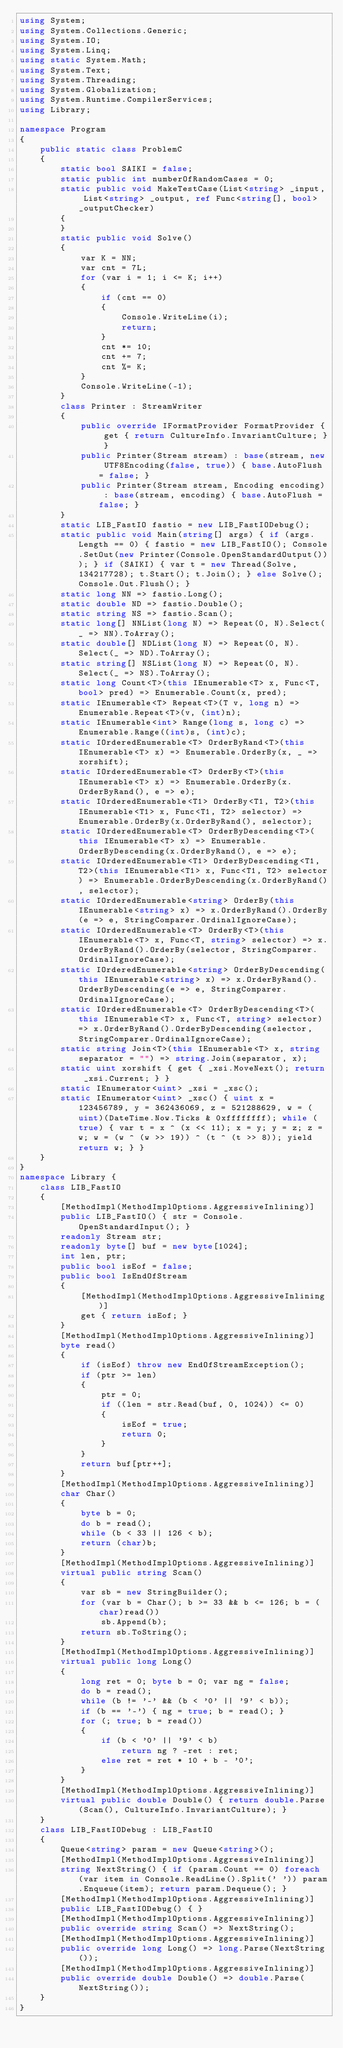Convert code to text. <code><loc_0><loc_0><loc_500><loc_500><_C#_>using System;
using System.Collections.Generic;
using System.IO;
using System.Linq;
using static System.Math;
using System.Text;
using System.Threading;
using System.Globalization;
using System.Runtime.CompilerServices;
using Library;

namespace Program
{
    public static class ProblemC
    {
        static bool SAIKI = false;
        static public int numberOfRandomCases = 0;
        static public void MakeTestCase(List<string> _input, List<string> _output, ref Func<string[], bool> _outputChecker)
        {
        }
        static public void Solve()
        {
            var K = NN;
            var cnt = 7L;
            for (var i = 1; i <= K; i++)
            {
                if (cnt == 0)
                {
                    Console.WriteLine(i);
                    return;
                }
                cnt *= 10;
                cnt += 7;
                cnt %= K;
            }
            Console.WriteLine(-1);
        }
        class Printer : StreamWriter
        {
            public override IFormatProvider FormatProvider { get { return CultureInfo.InvariantCulture; } }
            public Printer(Stream stream) : base(stream, new UTF8Encoding(false, true)) { base.AutoFlush = false; }
            public Printer(Stream stream, Encoding encoding) : base(stream, encoding) { base.AutoFlush = false; }
        }
        static LIB_FastIO fastio = new LIB_FastIODebug();
        static public void Main(string[] args) { if (args.Length == 0) { fastio = new LIB_FastIO(); Console.SetOut(new Printer(Console.OpenStandardOutput())); } if (SAIKI) { var t = new Thread(Solve, 134217728); t.Start(); t.Join(); } else Solve(); Console.Out.Flush(); }
        static long NN => fastio.Long();
        static double ND => fastio.Double();
        static string NS => fastio.Scan();
        static long[] NNList(long N) => Repeat(0, N).Select(_ => NN).ToArray();
        static double[] NDList(long N) => Repeat(0, N).Select(_ => ND).ToArray();
        static string[] NSList(long N) => Repeat(0, N).Select(_ => NS).ToArray();
        static long Count<T>(this IEnumerable<T> x, Func<T, bool> pred) => Enumerable.Count(x, pred);
        static IEnumerable<T> Repeat<T>(T v, long n) => Enumerable.Repeat<T>(v, (int)n);
        static IEnumerable<int> Range(long s, long c) => Enumerable.Range((int)s, (int)c);
        static IOrderedEnumerable<T> OrderByRand<T>(this IEnumerable<T> x) => Enumerable.OrderBy(x, _ => xorshift);
        static IOrderedEnumerable<T> OrderBy<T>(this IEnumerable<T> x) => Enumerable.OrderBy(x.OrderByRand(), e => e);
        static IOrderedEnumerable<T1> OrderBy<T1, T2>(this IEnumerable<T1> x, Func<T1, T2> selector) => Enumerable.OrderBy(x.OrderByRand(), selector);
        static IOrderedEnumerable<T> OrderByDescending<T>(this IEnumerable<T> x) => Enumerable.OrderByDescending(x.OrderByRand(), e => e);
        static IOrderedEnumerable<T1> OrderByDescending<T1, T2>(this IEnumerable<T1> x, Func<T1, T2> selector) => Enumerable.OrderByDescending(x.OrderByRand(), selector);
        static IOrderedEnumerable<string> OrderBy(this IEnumerable<string> x) => x.OrderByRand().OrderBy(e => e, StringComparer.OrdinalIgnoreCase);
        static IOrderedEnumerable<T> OrderBy<T>(this IEnumerable<T> x, Func<T, string> selector) => x.OrderByRand().OrderBy(selector, StringComparer.OrdinalIgnoreCase);
        static IOrderedEnumerable<string> OrderByDescending(this IEnumerable<string> x) => x.OrderByRand().OrderByDescending(e => e, StringComparer.OrdinalIgnoreCase);
        static IOrderedEnumerable<T> OrderByDescending<T>(this IEnumerable<T> x, Func<T, string> selector) => x.OrderByRand().OrderByDescending(selector, StringComparer.OrdinalIgnoreCase);
        static string Join<T>(this IEnumerable<T> x, string separator = "") => string.Join(separator, x);
        static uint xorshift { get { _xsi.MoveNext(); return _xsi.Current; } }
        static IEnumerator<uint> _xsi = _xsc();
        static IEnumerator<uint> _xsc() { uint x = 123456789, y = 362436069, z = 521288629, w = (uint)(DateTime.Now.Ticks & 0xffffffff); while (true) { var t = x ^ (x << 11); x = y; y = z; z = w; w = (w ^ (w >> 19)) ^ (t ^ (t >> 8)); yield return w; } }
    }
}
namespace Library {
    class LIB_FastIO
    {
        [MethodImpl(MethodImplOptions.AggressiveInlining)]
        public LIB_FastIO() { str = Console.OpenStandardInput(); }
        readonly Stream str;
        readonly byte[] buf = new byte[1024];
        int len, ptr;
        public bool isEof = false;
        public bool IsEndOfStream
        {
            [MethodImpl(MethodImplOptions.AggressiveInlining)]
            get { return isEof; }
        }
        [MethodImpl(MethodImplOptions.AggressiveInlining)]
        byte read()
        {
            if (isEof) throw new EndOfStreamException();
            if (ptr >= len)
            {
                ptr = 0;
                if ((len = str.Read(buf, 0, 1024)) <= 0)
                {
                    isEof = true;
                    return 0;
                }
            }
            return buf[ptr++];
        }
        [MethodImpl(MethodImplOptions.AggressiveInlining)]
        char Char()
        {
            byte b = 0;
            do b = read();
            while (b < 33 || 126 < b);
            return (char)b;
        }
        [MethodImpl(MethodImplOptions.AggressiveInlining)]
        virtual public string Scan()
        {
            var sb = new StringBuilder();
            for (var b = Char(); b >= 33 && b <= 126; b = (char)read())
                sb.Append(b);
            return sb.ToString();
        }
        [MethodImpl(MethodImplOptions.AggressiveInlining)]
        virtual public long Long()
        {
            long ret = 0; byte b = 0; var ng = false;
            do b = read();
            while (b != '-' && (b < '0' || '9' < b));
            if (b == '-') { ng = true; b = read(); }
            for (; true; b = read())
            {
                if (b < '0' || '9' < b)
                    return ng ? -ret : ret;
                else ret = ret * 10 + b - '0';
            }
        }
        [MethodImpl(MethodImplOptions.AggressiveInlining)]
        virtual public double Double() { return double.Parse(Scan(), CultureInfo.InvariantCulture); }
    }
    class LIB_FastIODebug : LIB_FastIO
    {
        Queue<string> param = new Queue<string>();
        [MethodImpl(MethodImplOptions.AggressiveInlining)]
        string NextString() { if (param.Count == 0) foreach (var item in Console.ReadLine().Split(' ')) param.Enqueue(item); return param.Dequeue(); }
        [MethodImpl(MethodImplOptions.AggressiveInlining)]
        public LIB_FastIODebug() { }
        [MethodImpl(MethodImplOptions.AggressiveInlining)]
        public override string Scan() => NextString();
        [MethodImpl(MethodImplOptions.AggressiveInlining)]
        public override long Long() => long.Parse(NextString());
        [MethodImpl(MethodImplOptions.AggressiveInlining)]
        public override double Double() => double.Parse(NextString());
    }
}
</code> 